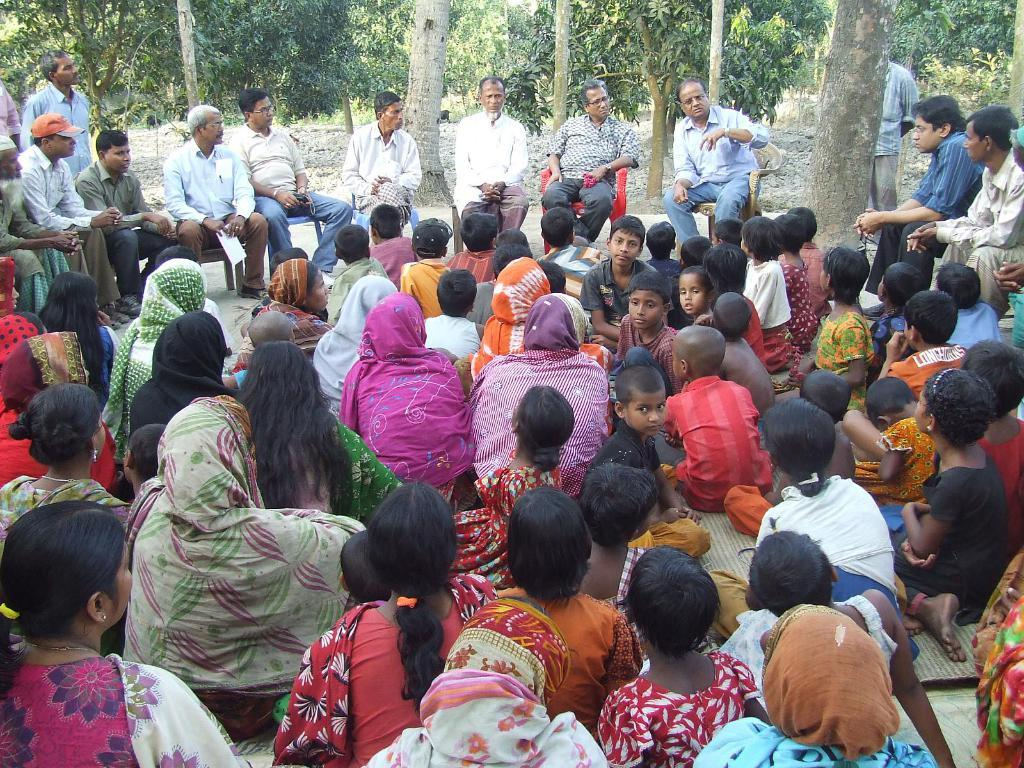What are the people in the image doing? The people in the image are sitting on the ground and chairs. Is there any object being held by someone in the image? Yes, there is a person holding a paper. What can be seen in the background of the image? The sky is visible in the background of the image. What type of bird can be seen bursting through the paper in the image? There is no bird present in the image, nor is there any indication of a paper being burst through. 